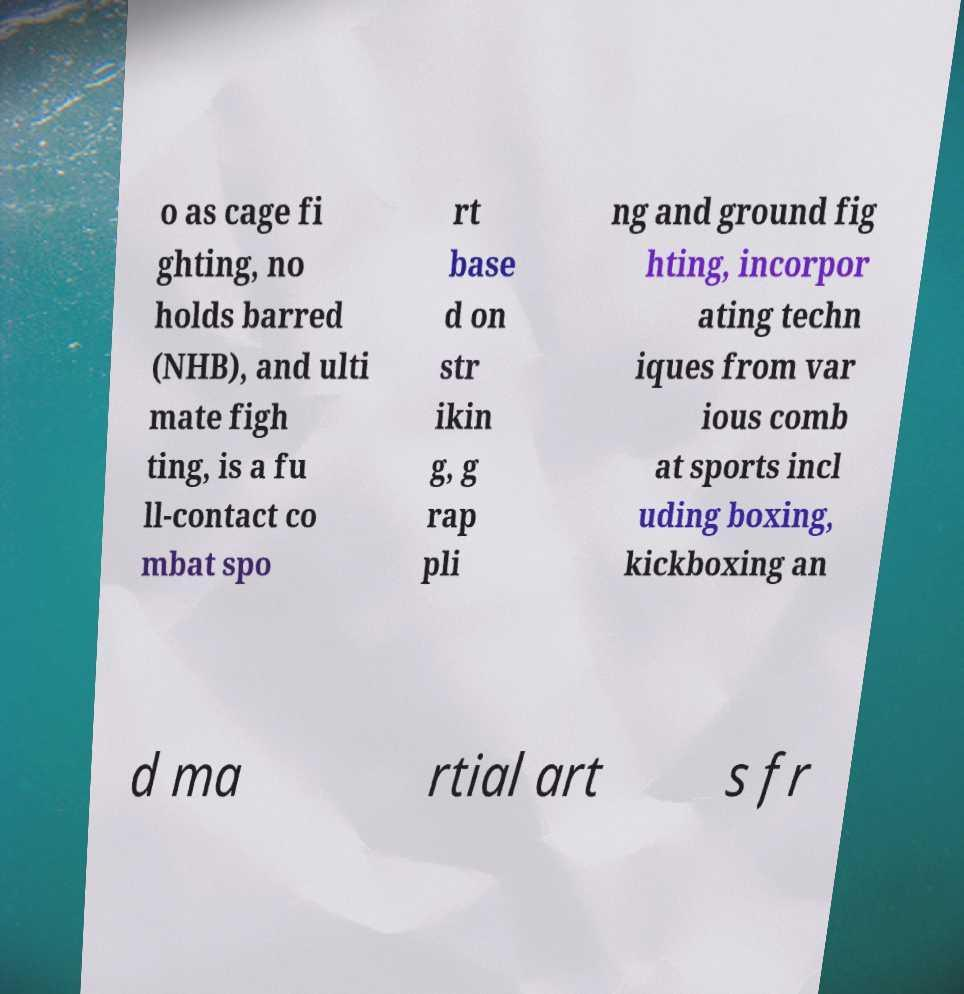Please read and relay the text visible in this image. What does it say? o as cage fi ghting, no holds barred (NHB), and ulti mate figh ting, is a fu ll-contact co mbat spo rt base d on str ikin g, g rap pli ng and ground fig hting, incorpor ating techn iques from var ious comb at sports incl uding boxing, kickboxing an d ma rtial art s fr 